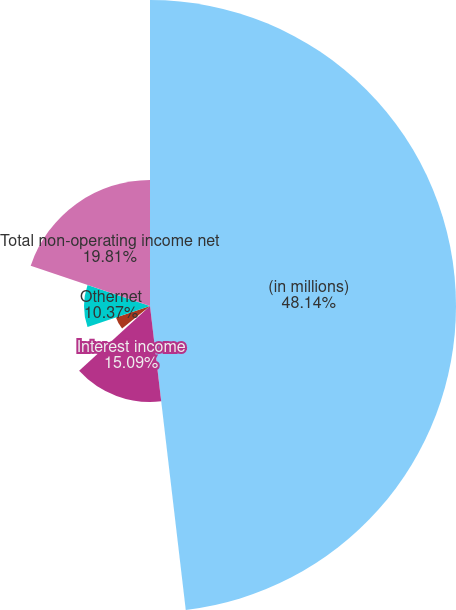Convert chart to OTSL. <chart><loc_0><loc_0><loc_500><loc_500><pie_chart><fcel>(in millions)<fcel>Interest income<fcel>Foreign currency gains net<fcel>Minority interests<fcel>Othernet<fcel>Total non-operating income net<nl><fcel>48.13%<fcel>15.09%<fcel>0.94%<fcel>5.65%<fcel>10.37%<fcel>19.81%<nl></chart> 